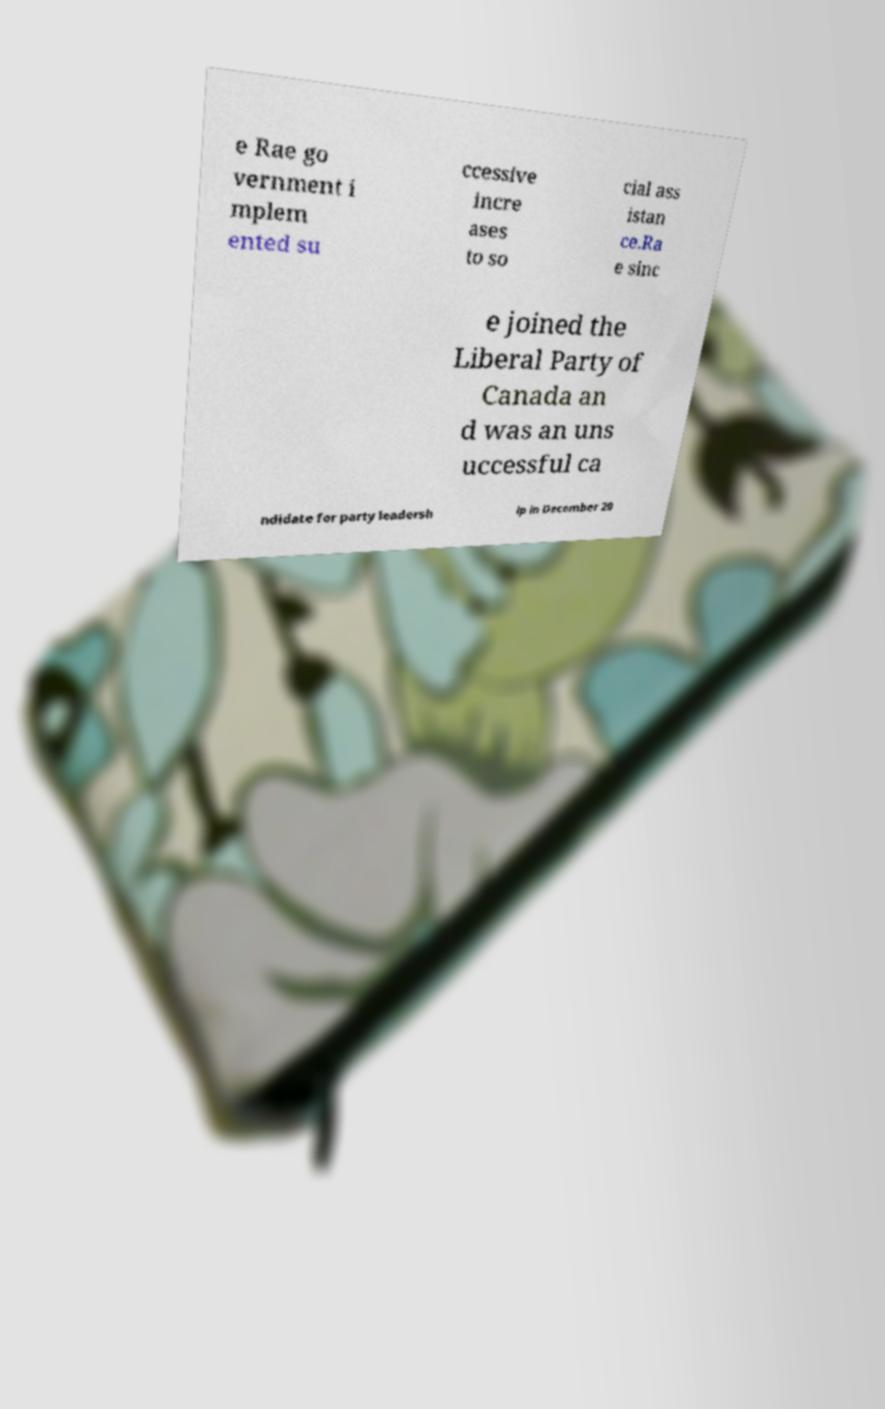Please identify and transcribe the text found in this image. e Rae go vernment i mplem ented su ccessive incre ases to so cial ass istan ce.Ra e sinc e joined the Liberal Party of Canada an d was an uns uccessful ca ndidate for party leadersh ip in December 20 